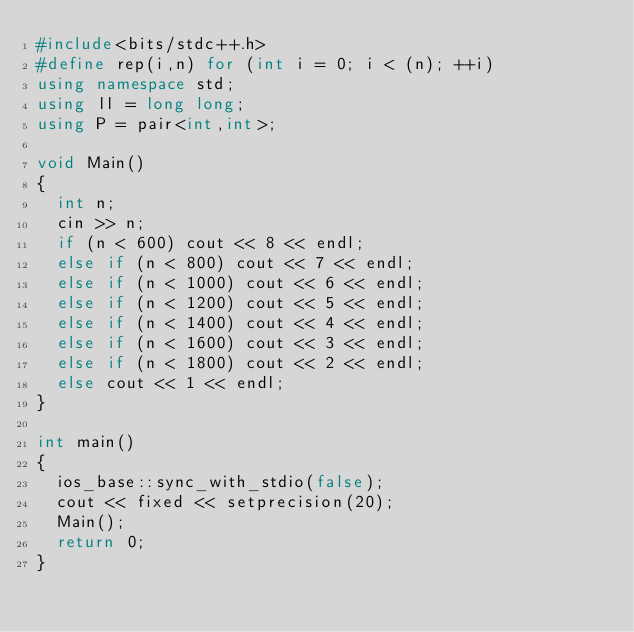<code> <loc_0><loc_0><loc_500><loc_500><_C++_>#include<bits/stdc++.h>
#define rep(i,n) for (int i = 0; i < (n); ++i)
using namespace std;
using ll = long long;
using P = pair<int,int>;

void Main()
{
  int n;
  cin >> n;
  if (n < 600) cout << 8 << endl;
  else if (n < 800) cout << 7 << endl;
  else if (n < 1000) cout << 6 << endl;
  else if (n < 1200) cout << 5 << endl;
  else if (n < 1400) cout << 4 << endl;
  else if (n < 1600) cout << 3 << endl;
  else if (n < 1800) cout << 2 << endl;
  else cout << 1 << endl;
}

int main()
{
  ios_base::sync_with_stdio(false);
  cout << fixed << setprecision(20);
  Main();
  return 0;
}
</code> 